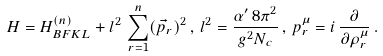Convert formula to latex. <formula><loc_0><loc_0><loc_500><loc_500>H = H _ { B F K L } ^ { ( n ) } + l ^ { 2 } \, \sum _ { r = 1 } ^ { n } ( \vec { p } _ { r } ) ^ { 2 } \, , \, l ^ { 2 } = \frac { \alpha ^ { \prime } \, 8 \pi ^ { 2 } } { g ^ { 2 } N _ { c } } \, , \, p _ { r } ^ { \mu } = i \, \frac { \partial } { \partial \rho _ { r } ^ { \mu } } \, .</formula> 